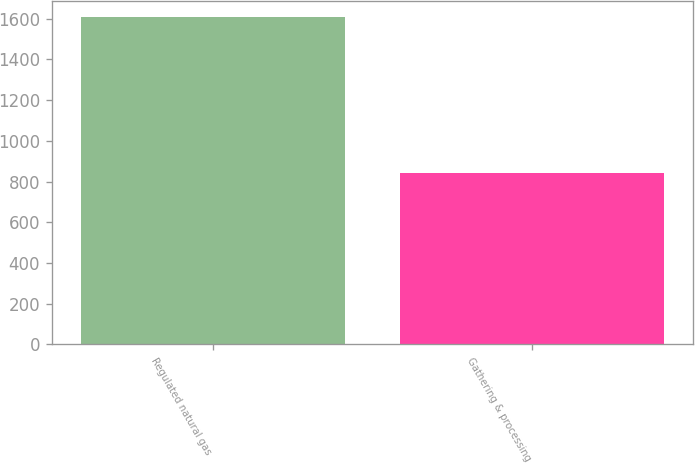Convert chart. <chart><loc_0><loc_0><loc_500><loc_500><bar_chart><fcel>Regulated natural gas<fcel>Gathering & processing<nl><fcel>1609<fcel>844<nl></chart> 